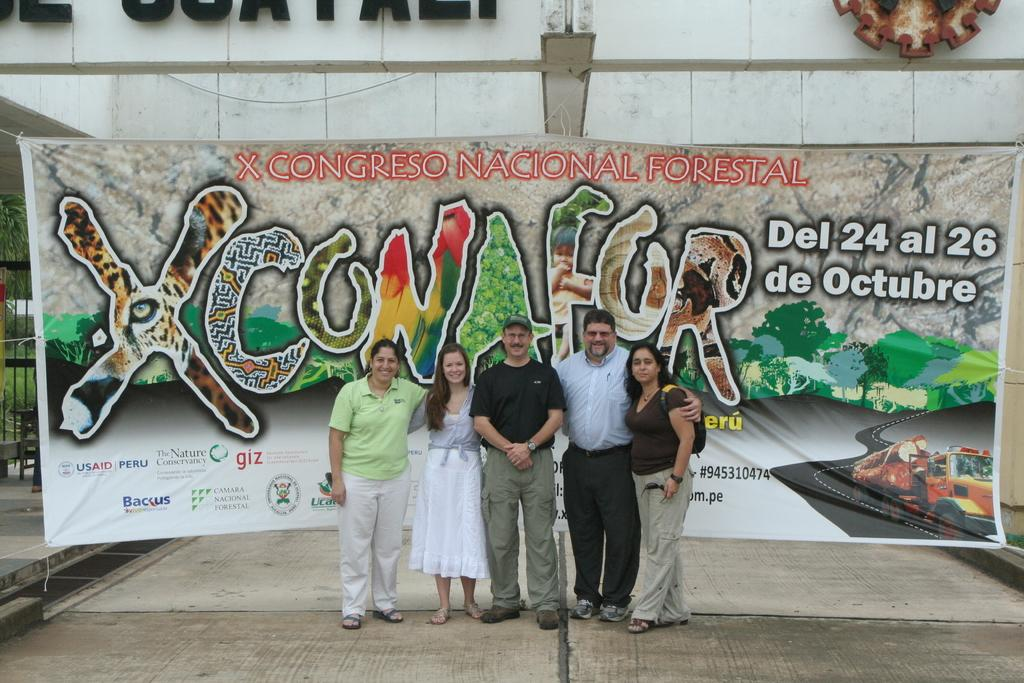How many people are present in the image? There are five persons standing in the image. What is the facial expression of the people in the image? The persons are smiling. What can be seen in the background of the image? There is a banner, a building, a gate, a stool, plants, and trees in the background of the image. What type of stamp can be seen on the banner in the image? There is no stamp present on the banner in the image. What kind of beast is lurking behind the persons in the image? There is no beast present in the image; the background features a banner, a building, a gate, a stool, plants, and trees. 